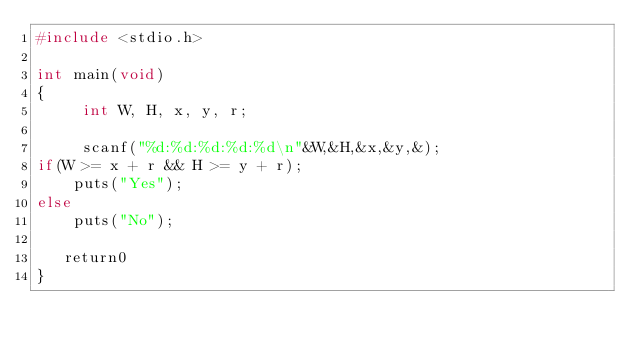<code> <loc_0><loc_0><loc_500><loc_500><_C_>#include <stdio.h>

int main(void)
{
     int W, H, x, y, r;

     scanf("%d:%d:%d:%d:%d\n"&W,&H,&x,&y,&);
if(W >= x + r && H >= y + r);
    puts("Yes");
else
    puts("No");

   return0
}
     
</code> 